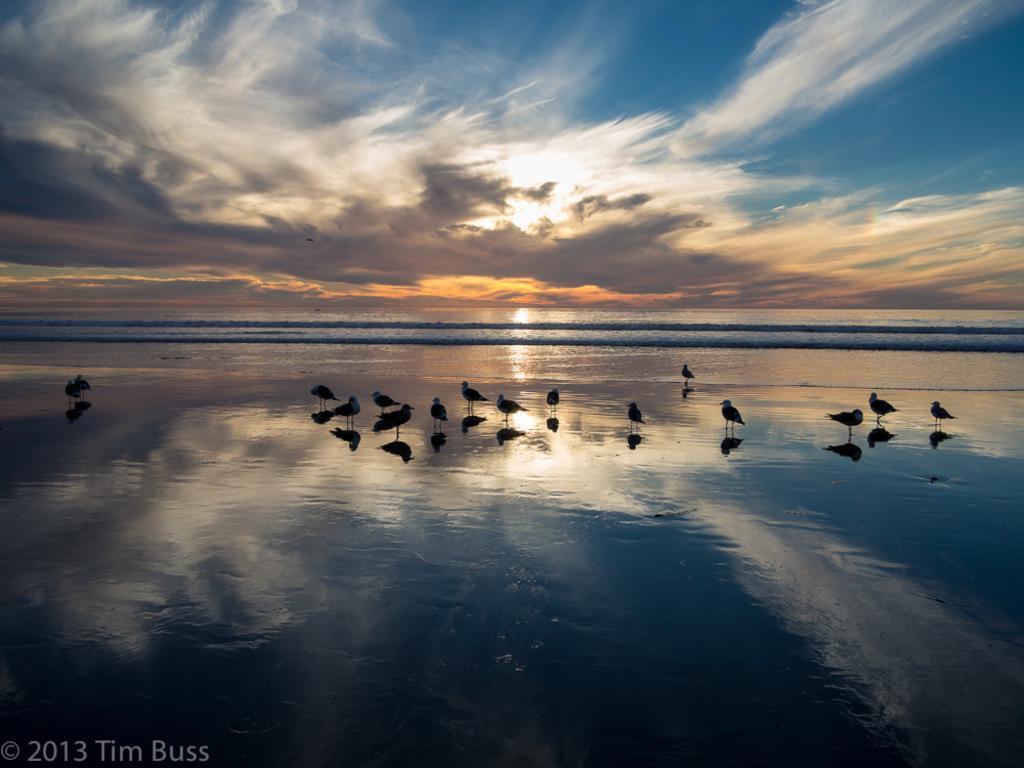Could you give a brief overview of what you see in this image? In the middle I can see flocks of birds on the beach, text and water. In the background I can see the sky. This image is taken may be on the sandy beach. 